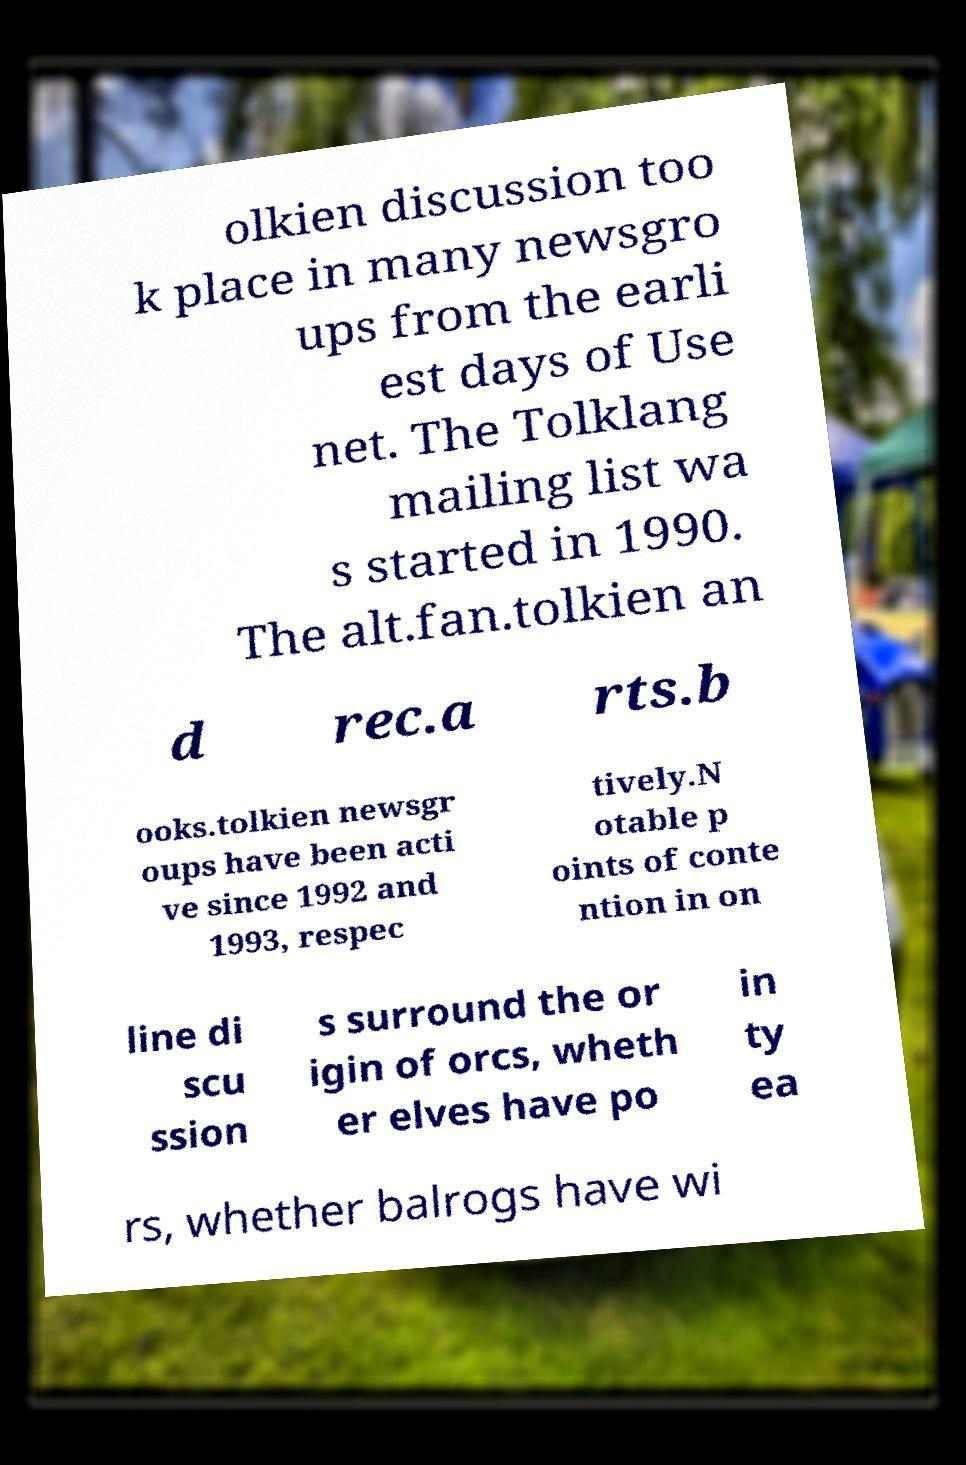There's text embedded in this image that I need extracted. Can you transcribe it verbatim? olkien discussion too k place in many newsgro ups from the earli est days of Use net. The Tolklang mailing list wa s started in 1990. The alt.fan.tolkien an d rec.a rts.b ooks.tolkien newsgr oups have been acti ve since 1992 and 1993, respec tively.N otable p oints of conte ntion in on line di scu ssion s surround the or igin of orcs, wheth er elves have po in ty ea rs, whether balrogs have wi 